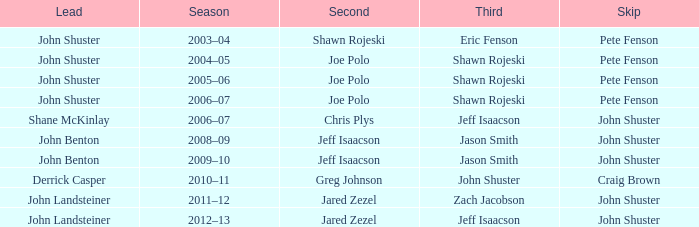Which season has Zach Jacobson in third? 2011–12. 